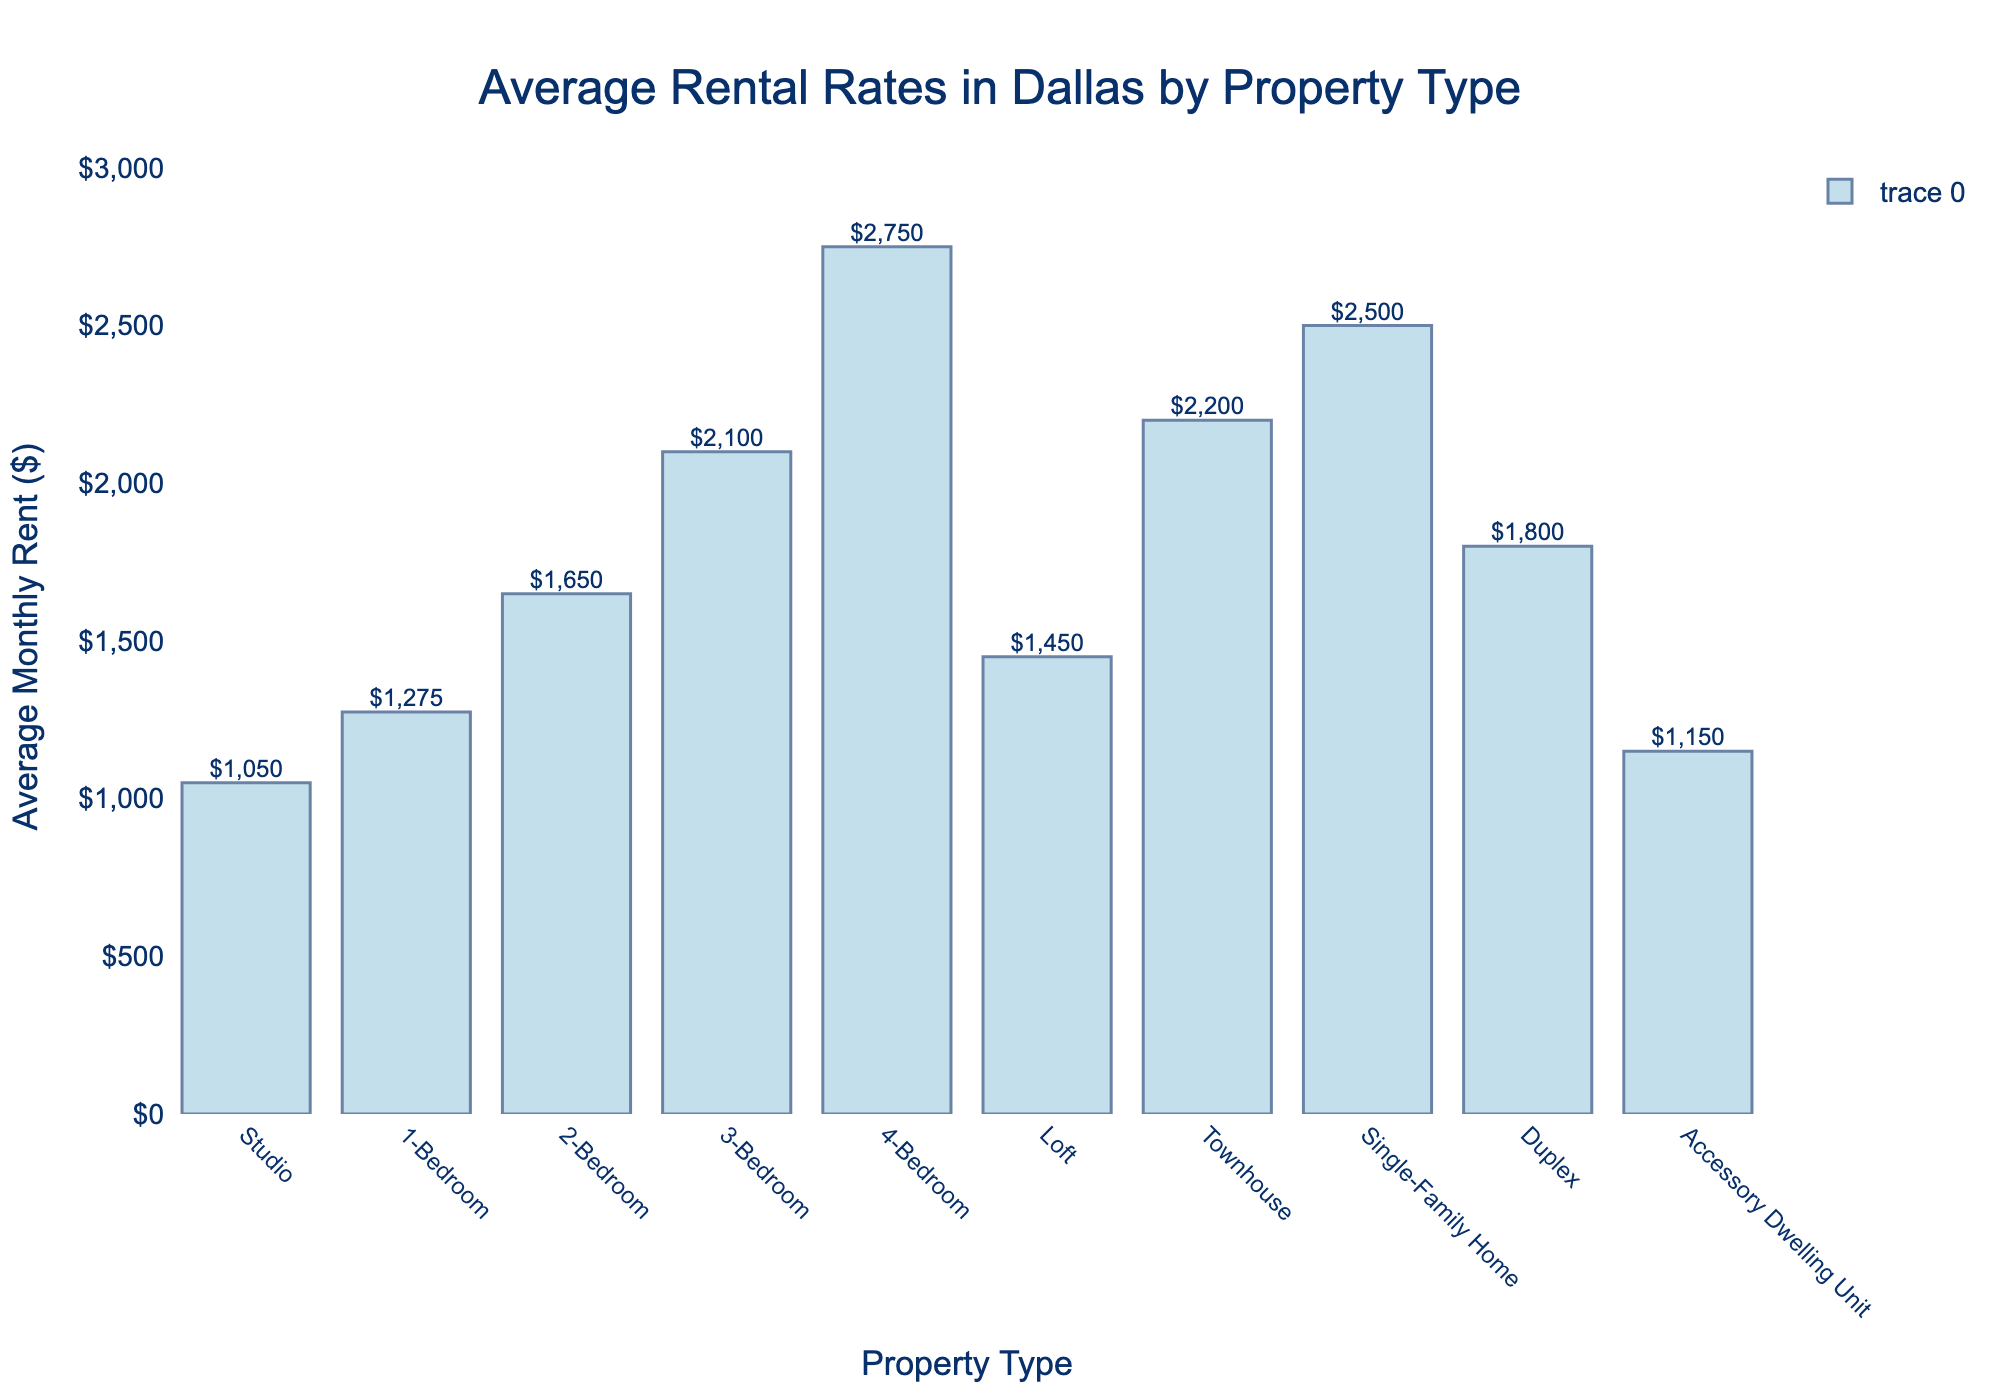What is the property type with the highest average monthly rent? First, locate the tallest bar in the chart. The tallest bar represents the property type with the highest average monthly rent. In this case, it is the "4-Bedroom" property.
Answer: 4-Bedroom Which property type has the lowest average monthly rent? Identify the shortest bar in the chart. The shortest bar corresponds to the property type with the lowest monthly rent, which is "Studio".
Answer: Studio How much more expensive is the average rent for a 3-Bedroom property compared to a Studio? Find the average rents for both 3-Bedroom and Studio properties. Subtract the Studio rent from the 3-Bedroom rent: $2100 - $1050.
Answer: $1050 What is the sum of the average rents for a 1-Bedroom and a Loft? Find the average rents for both 1-Bedroom and Loft properties. Sum the two values: $1275 + $1450.
Answer: $2725 Is the average monthly rent for a Single-Family Home higher than for a Townhouse? Compare the heights of the bars for Single-Family Home and Townhouse. The bar for Single-Family Home is taller, indicating a higher average rent.
Answer: Yes What is the difference between the average monthly rents of a Duplex and an Accessory Dwelling Unit? Find the average rents for both Duplex and Accessory Dwelling Unit properties. Subtract the latter from the former: $1800 - $1150.
Answer: $650 Which property types have an average monthly rent between $1200 and $2000? Identify the bars with average rents falling within the range $1200 to $2000. These are 1-Bedroom, Loft, and Duplex.
Answer: 1-Bedroom, Loft, Duplex Calculate the average of the monthly rents for Studio, 1-Bedroom, and 2-Bedroom properties. Sum the average rents for these property types and then divide by the number of property types: ($1050 + $1275 + $1650) / 3.
Answer: $1325 Is the height of the 4-Bedroom rent bar more than twice the height of the 2-Bedroom rent bar? Compare the heights of the bars for 4-Bedroom and 2-Bedroom. 4-Bedroom rent is $2750, and twice the 2-Bedroom rent is $1650 * 2 = $3300. Since $2750 is less than $3300, the answer is no.
Answer: No 